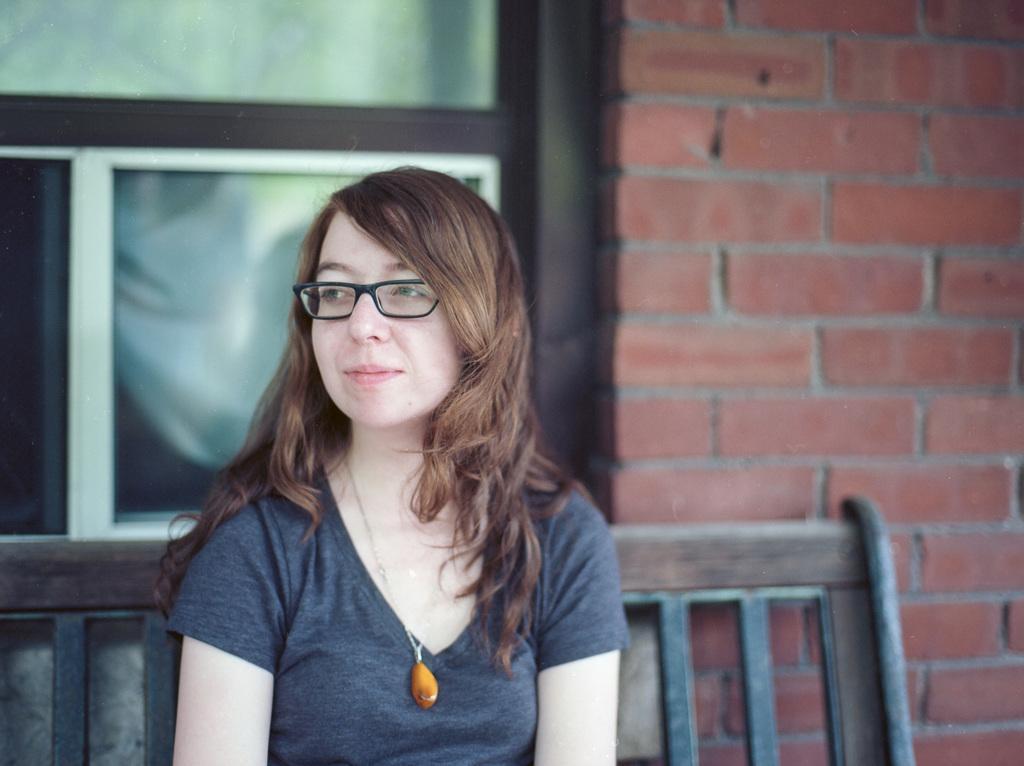Can you describe this image briefly? In the image in the center, we can see one woman sitting on the bench. And she is smiling, which we can see on her face. In the background there is a brick wall and window. 